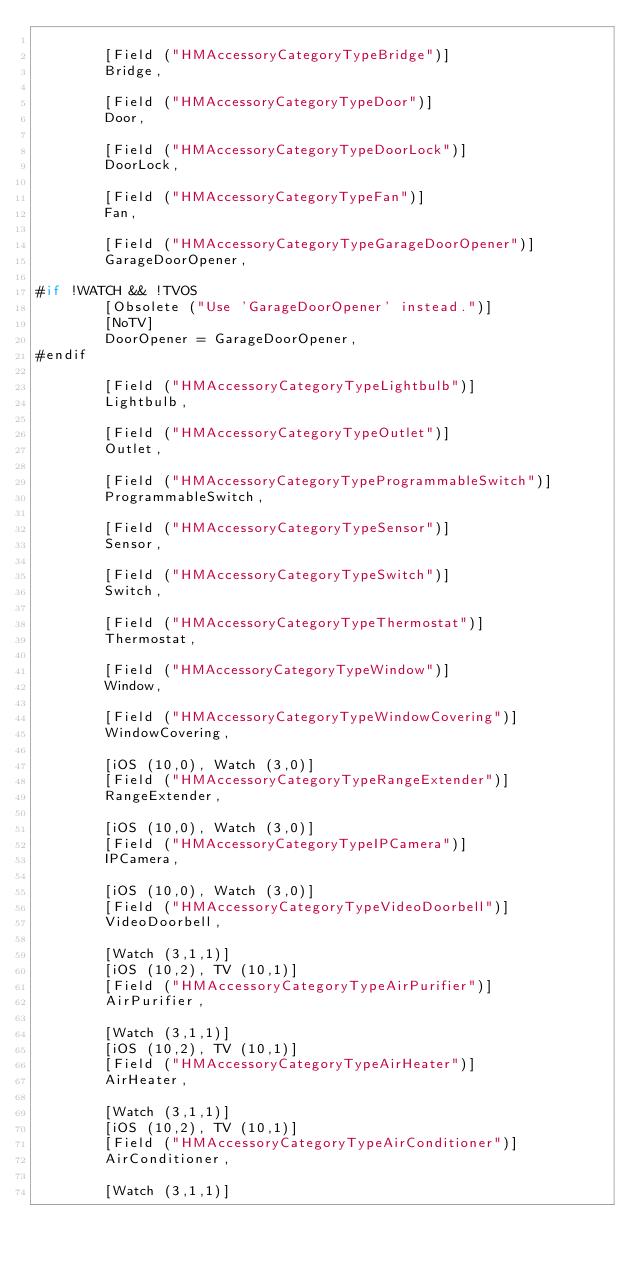<code> <loc_0><loc_0><loc_500><loc_500><_C#_>
		[Field ("HMAccessoryCategoryTypeBridge")]
		Bridge,

		[Field ("HMAccessoryCategoryTypeDoor")]
		Door,

		[Field ("HMAccessoryCategoryTypeDoorLock")]
		DoorLock,

		[Field ("HMAccessoryCategoryTypeFan")]
		Fan,

		[Field ("HMAccessoryCategoryTypeGarageDoorOpener")]
		GarageDoorOpener,

#if !WATCH && !TVOS
		[Obsolete ("Use 'GarageDoorOpener' instead.")]
		[NoTV]
		DoorOpener = GarageDoorOpener,
#endif

		[Field ("HMAccessoryCategoryTypeLightbulb")]
		Lightbulb,

		[Field ("HMAccessoryCategoryTypeOutlet")]
		Outlet,

		[Field ("HMAccessoryCategoryTypeProgrammableSwitch")]
		ProgrammableSwitch,

		[Field ("HMAccessoryCategoryTypeSensor")]
		Sensor,

		[Field ("HMAccessoryCategoryTypeSwitch")]
		Switch,

		[Field ("HMAccessoryCategoryTypeThermostat")]
		Thermostat,

		[Field ("HMAccessoryCategoryTypeWindow")]
		Window,

		[Field ("HMAccessoryCategoryTypeWindowCovering")]
		WindowCovering,

		[iOS (10,0), Watch (3,0)]
		[Field ("HMAccessoryCategoryTypeRangeExtender")]
		RangeExtender,

		[iOS (10,0), Watch (3,0)]
		[Field ("HMAccessoryCategoryTypeIPCamera")]
		IPCamera,

		[iOS (10,0), Watch (3,0)]
		[Field ("HMAccessoryCategoryTypeVideoDoorbell")]
		VideoDoorbell,

		[Watch (3,1,1)]
		[iOS (10,2), TV (10,1)]
		[Field ("HMAccessoryCategoryTypeAirPurifier")]
		AirPurifier,

		[Watch (3,1,1)]
		[iOS (10,2), TV (10,1)]
		[Field ("HMAccessoryCategoryTypeAirHeater")]
		AirHeater,

		[Watch (3,1,1)]
		[iOS (10,2), TV (10,1)]
		[Field ("HMAccessoryCategoryTypeAirConditioner")]
		AirConditioner,

		[Watch (3,1,1)]</code> 